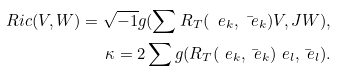Convert formula to latex. <formula><loc_0><loc_0><loc_500><loc_500>R i c ( V , W ) = \sqrt { - 1 } g ( \sum R _ { T } ( \ e _ { k } , \bar { \ e } _ { k } ) V , J W ) , \\ \kappa = 2 \sum g ( R _ { T } ( \ e _ { k } , \bar { \ e } _ { k } ) \ e _ { l } , \bar { \ e } _ { l } ) .</formula> 